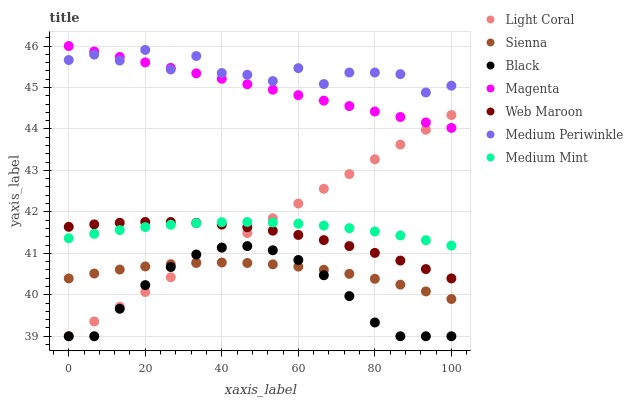Does Black have the minimum area under the curve?
Answer yes or no. Yes. Does Medium Periwinkle have the maximum area under the curve?
Answer yes or no. Yes. Does Sienna have the minimum area under the curve?
Answer yes or no. No. Does Sienna have the maximum area under the curve?
Answer yes or no. No. Is Magenta the smoothest?
Answer yes or no. Yes. Is Medium Periwinkle the roughest?
Answer yes or no. Yes. Is Sienna the smoothest?
Answer yes or no. No. Is Sienna the roughest?
Answer yes or no. No. Does Light Coral have the lowest value?
Answer yes or no. Yes. Does Sienna have the lowest value?
Answer yes or no. No. Does Magenta have the highest value?
Answer yes or no. Yes. Does Medium Periwinkle have the highest value?
Answer yes or no. No. Is Sienna less than Medium Periwinkle?
Answer yes or no. Yes. Is Medium Periwinkle greater than Web Maroon?
Answer yes or no. Yes. Does Light Coral intersect Magenta?
Answer yes or no. Yes. Is Light Coral less than Magenta?
Answer yes or no. No. Is Light Coral greater than Magenta?
Answer yes or no. No. Does Sienna intersect Medium Periwinkle?
Answer yes or no. No. 